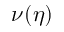<formula> <loc_0><loc_0><loc_500><loc_500>\nu ( \eta )</formula> 